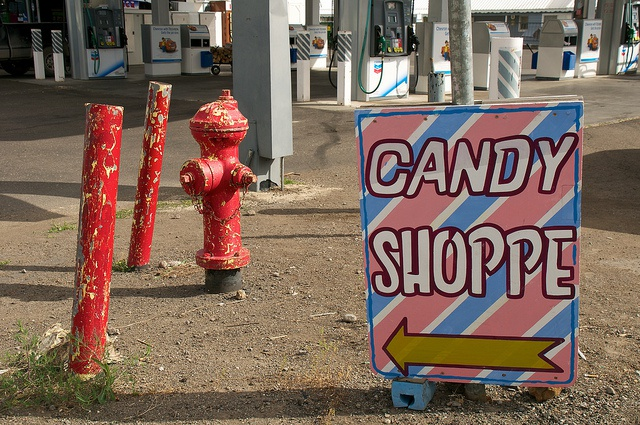Describe the objects in this image and their specific colors. I can see fire hydrant in black, maroon, salmon, and brown tones and car in black and gray tones in this image. 